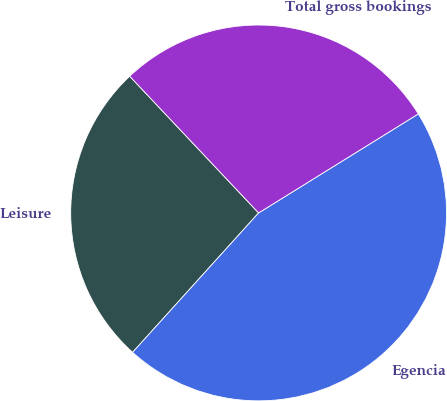<chart> <loc_0><loc_0><loc_500><loc_500><pie_chart><fcel>Leisure<fcel>Egencia<fcel>Total gross bookings<nl><fcel>26.27%<fcel>45.53%<fcel>28.2%<nl></chart> 